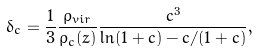<formula> <loc_0><loc_0><loc_500><loc_500>\delta _ { c } = \frac { 1 } { 3 } \frac { \rho _ { v i r } } { \rho _ { c } ( z ) } \frac { c ^ { 3 } } { \ln ( 1 + c ) - c / ( 1 + c ) } ,</formula> 